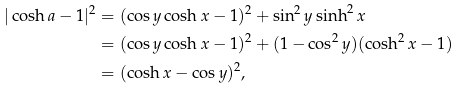<formula> <loc_0><loc_0><loc_500><loc_500>| \cosh { a } - 1 | ^ { 2 } & = ( \cos { y } \cosh { x } - 1 ) ^ { 2 } + \sin ^ { 2 } { y } \sinh ^ { 2 } { x } \\ & = ( \cos { y } \cosh { x } - 1 ) ^ { 2 } + ( 1 - \cos ^ { 2 } { y } ) ( \cosh ^ { 2 } { x } - 1 ) \\ & = ( \cosh { x } - \cos { y } ) ^ { 2 } ,</formula> 